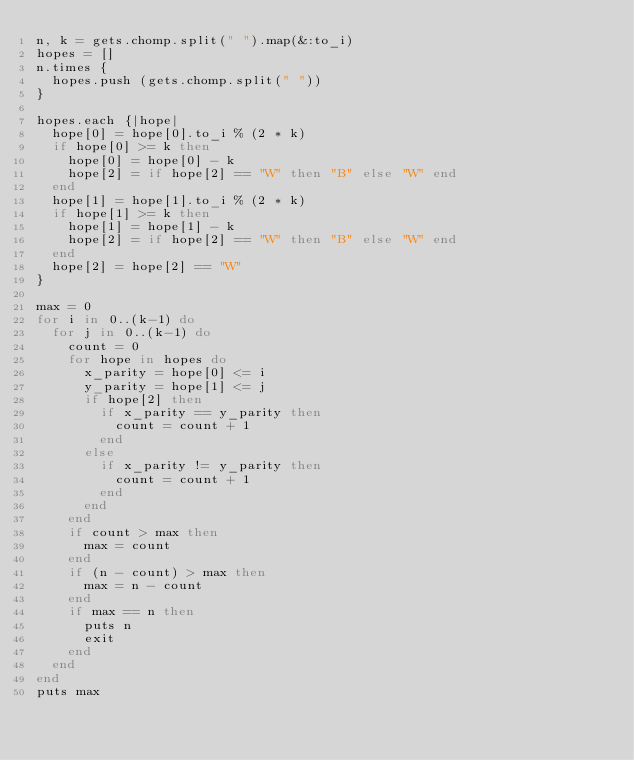<code> <loc_0><loc_0><loc_500><loc_500><_Ruby_>n, k = gets.chomp.split(" ").map(&:to_i)
hopes = []
n.times {
  hopes.push (gets.chomp.split(" "))
}

hopes.each {|hope|
  hope[0] = hope[0].to_i % (2 * k)
  if hope[0] >= k then
    hope[0] = hope[0] - k
    hope[2] = if hope[2] == "W" then "B" else "W" end
  end
  hope[1] = hope[1].to_i % (2 * k)
  if hope[1] >= k then
    hope[1] = hope[1] - k
    hope[2] = if hope[2] == "W" then "B" else "W" end
  end
  hope[2] = hope[2] == "W"
}

max = 0
for i in 0..(k-1) do
  for j in 0..(k-1) do
    count = 0
    for hope in hopes do
      x_parity = hope[0] <= i
      y_parity = hope[1] <= j
      if hope[2] then
        if x_parity == y_parity then
          count = count + 1
        end
      else
        if x_parity != y_parity then
          count = count + 1
        end
      end
    end
    if count > max then
      max = count
    end
    if (n - count) > max then
      max = n - count
    end
    if max == n then
      puts n
      exit
    end
  end
end
puts max
</code> 